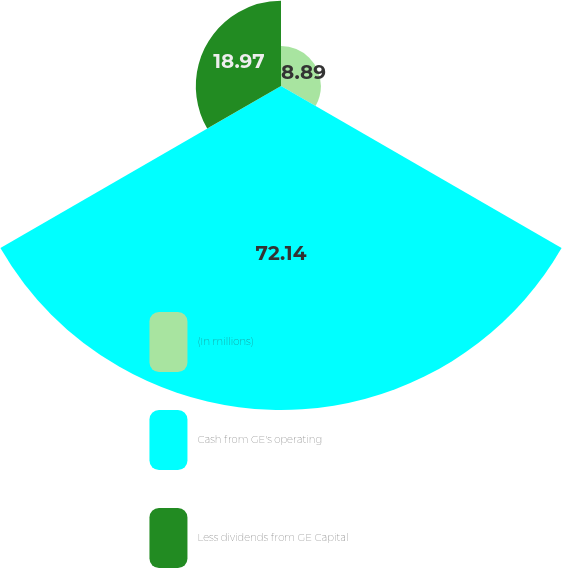Convert chart. <chart><loc_0><loc_0><loc_500><loc_500><pie_chart><fcel>(In millions)<fcel>Cash from GE's operating<fcel>Less dividends from GE Capital<nl><fcel>8.89%<fcel>72.14%<fcel>18.97%<nl></chart> 